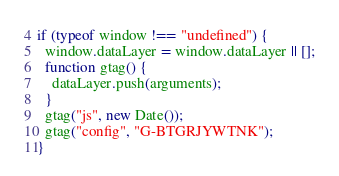<code> <loc_0><loc_0><loc_500><loc_500><_JavaScript_>if (typeof window !== "undefined") {
  window.dataLayer = window.dataLayer || [];
  function gtag() {
    dataLayer.push(arguments);
  }
  gtag("js", new Date());
  gtag("config", "G-BTGRJYWTNK");
}
</code> 